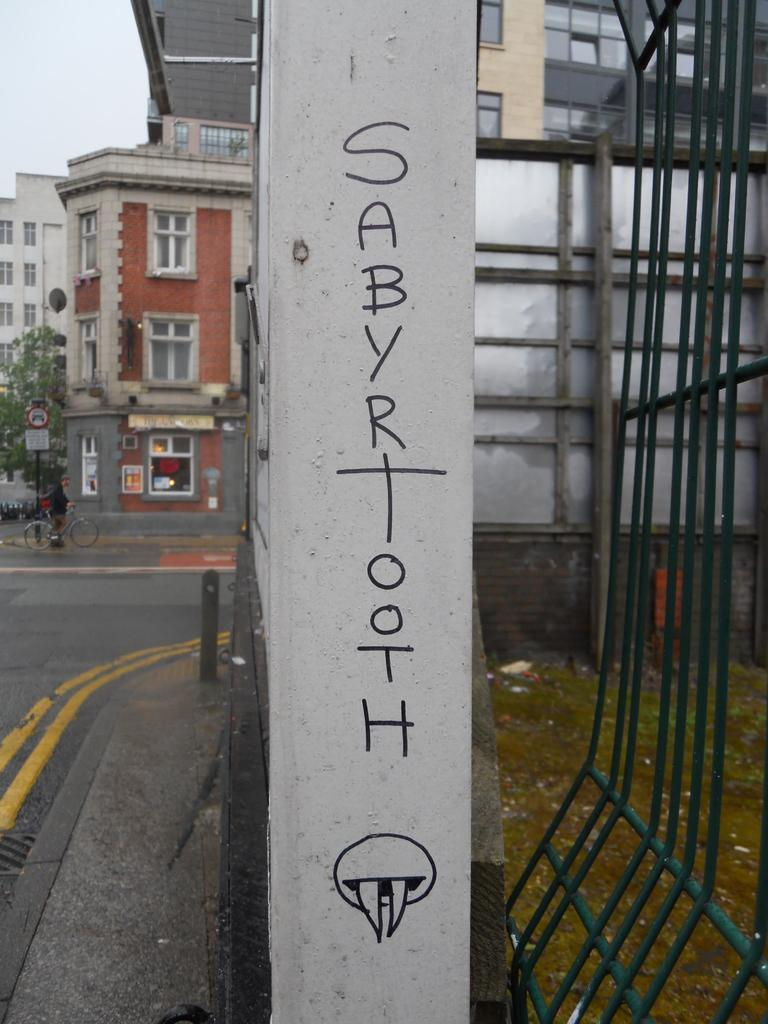What is on the pole in the image? There is a symbol on a pole, and there is text written on the pole. What can be seen in the background of the image? In the background, there is a road, a sign pole, a bicycle, a person, buildings, poles, windows, posters on the wall, glass doors, trees, and the sky. How much tax does the cart in the image have to pay? There is no cart present in the image, so there is no tax to consider. What type of lead can be seen connecting the poles in the image? There is no lead connecting the poles in the image; the poles are separate entities. 